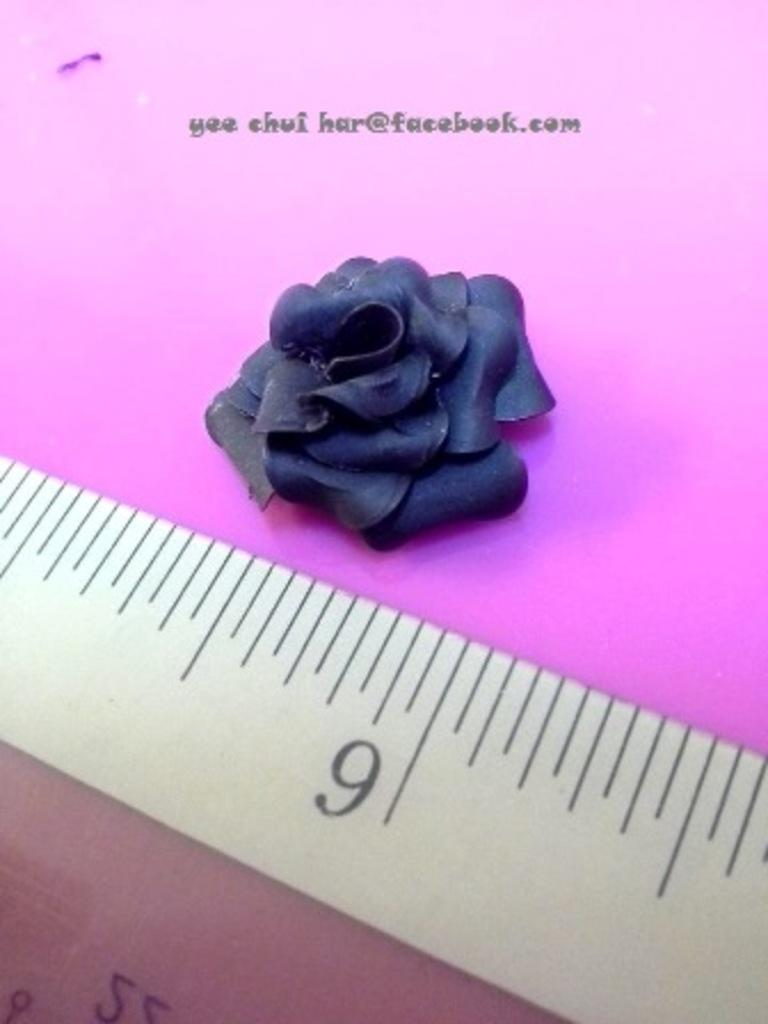Provide a one-sentence caption for the provided image. Yee chui har has a metal ruler on a pink background. 